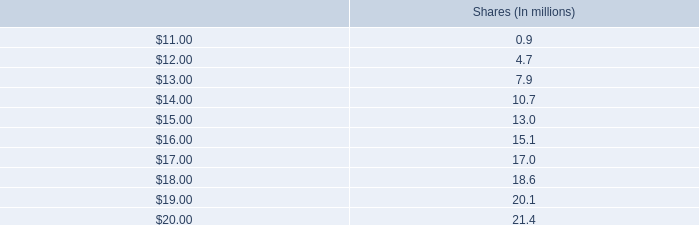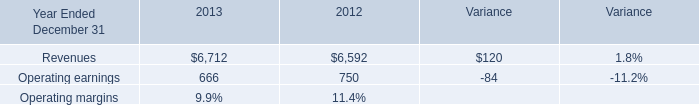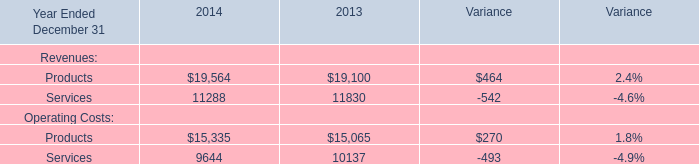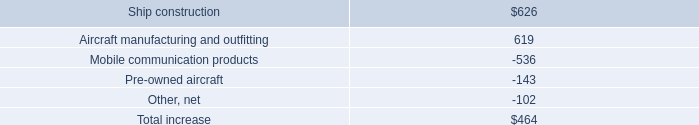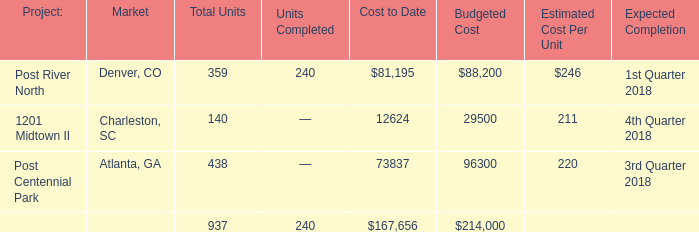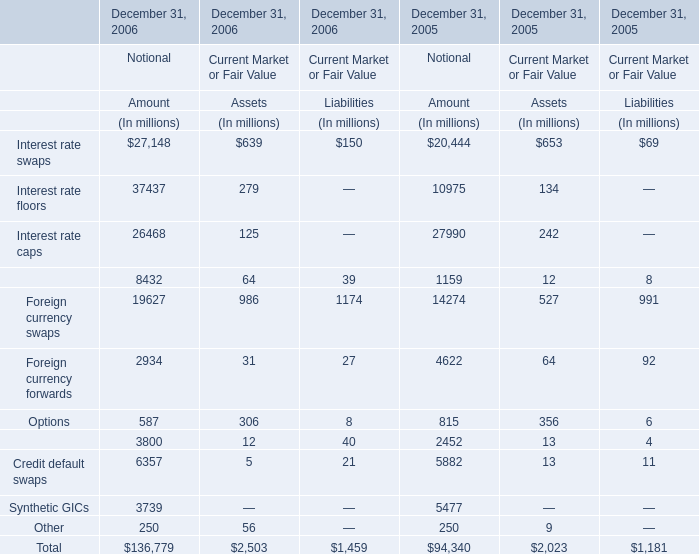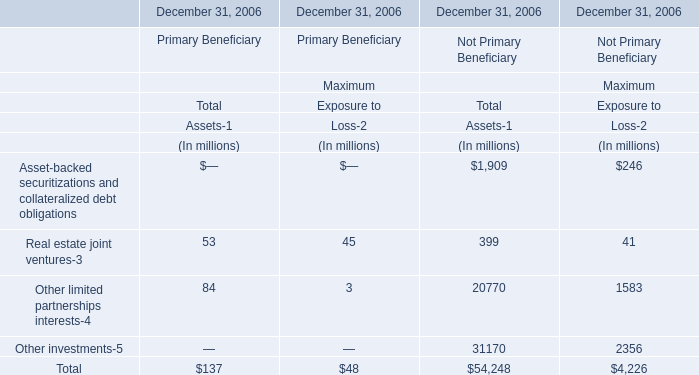What is the sum of Real estate joint ventures-3 of Maximum Exposure to for Primary Beneficiary and Operating earnings in 2012? (in million) 
Computations: (45 + 750)
Answer: 795.0. 